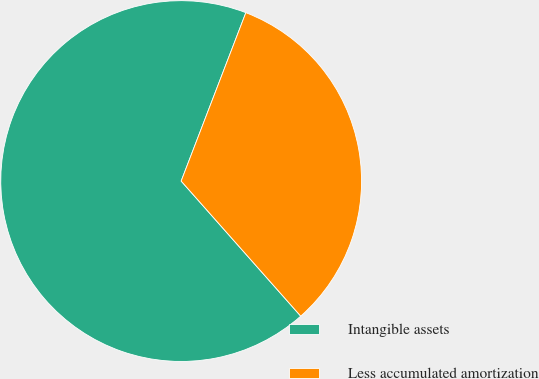Convert chart. <chart><loc_0><loc_0><loc_500><loc_500><pie_chart><fcel>Intangible assets<fcel>Less accumulated amortization<nl><fcel>67.37%<fcel>32.63%<nl></chart> 